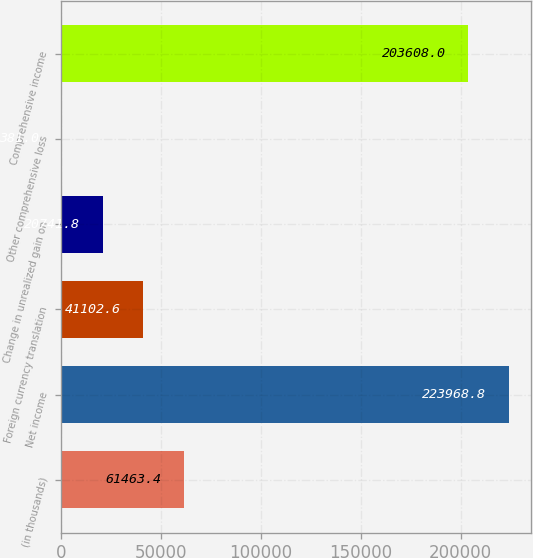Convert chart to OTSL. <chart><loc_0><loc_0><loc_500><loc_500><bar_chart><fcel>(in thousands)<fcel>Net income<fcel>Foreign currency translation<fcel>Change in unrealized gain on<fcel>Other comprehensive loss<fcel>Comprehensive income<nl><fcel>61463.4<fcel>223969<fcel>41102.6<fcel>20741.8<fcel>381<fcel>203608<nl></chart> 